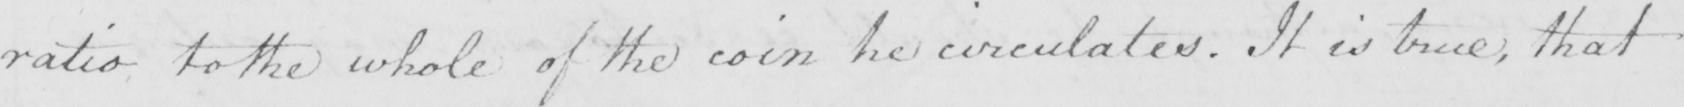Can you tell me what this handwritten text says? ratio to the whole of the coin he circulates . It is true , that 